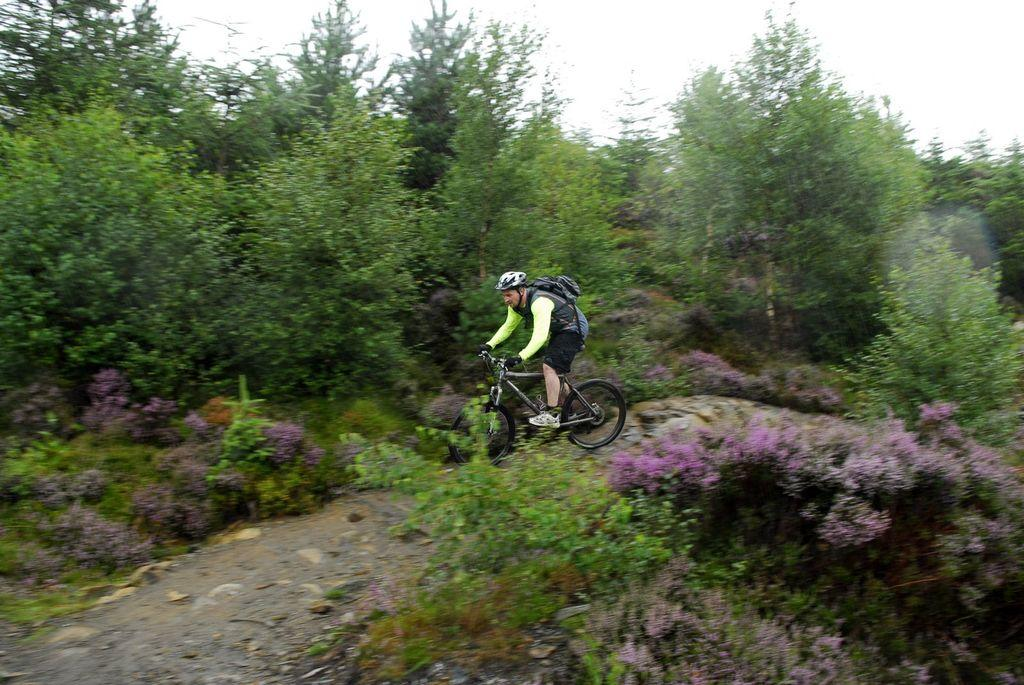What is the man doing in the image? The man is riding a bicycle in the image. What is the man wearing while riding the bicycle? The man is wearing a bag and a helmet. What can be seen in the background of the image? Trees and plants, as well as the sky, are visible in the background. What type of hair is the man wearing in the image? The man is wearing a helmet, not hair, in the image. How does the man fall off the bicycle in the image? There is no indication in the image that the man falls off the bicycle; he is shown riding it. 